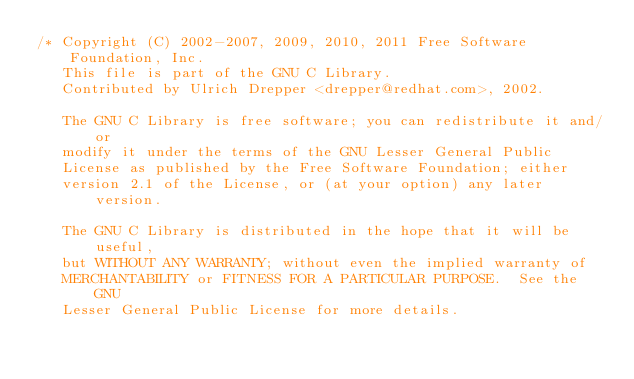<code> <loc_0><loc_0><loc_500><loc_500><_C_>/* Copyright (C) 2002-2007, 2009, 2010, 2011 Free Software Foundation, Inc.
   This file is part of the GNU C Library.
   Contributed by Ulrich Drepper <drepper@redhat.com>, 2002.

   The GNU C Library is free software; you can redistribute it and/or
   modify it under the terms of the GNU Lesser General Public
   License as published by the Free Software Foundation; either
   version 2.1 of the License, or (at your option) any later version.

   The GNU C Library is distributed in the hope that it will be useful,
   but WITHOUT ANY WARRANTY; without even the implied warranty of
   MERCHANTABILITY or FITNESS FOR A PARTICULAR PURPOSE.  See the GNU
   Lesser General Public License for more details.
</code> 